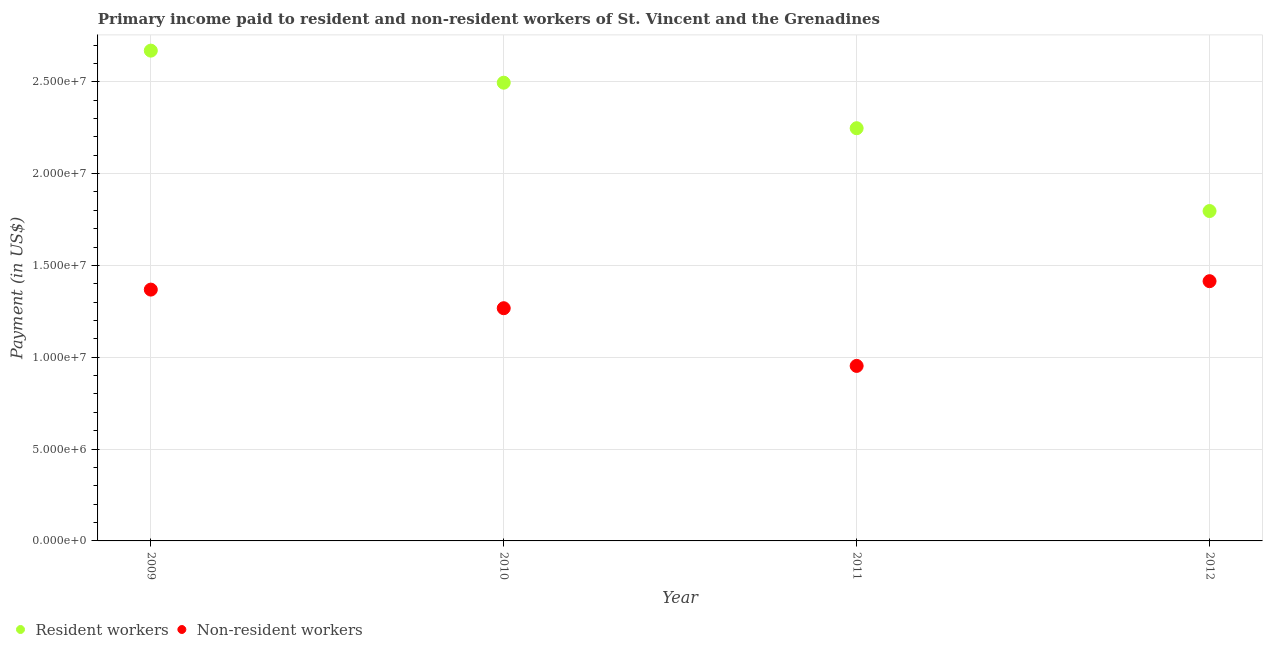How many different coloured dotlines are there?
Offer a terse response. 2. Is the number of dotlines equal to the number of legend labels?
Your answer should be very brief. Yes. What is the payment made to non-resident workers in 2010?
Your response must be concise. 1.27e+07. Across all years, what is the maximum payment made to non-resident workers?
Keep it short and to the point. 1.41e+07. Across all years, what is the minimum payment made to resident workers?
Your answer should be very brief. 1.80e+07. In which year was the payment made to non-resident workers maximum?
Offer a very short reply. 2012. In which year was the payment made to resident workers minimum?
Give a very brief answer. 2012. What is the total payment made to non-resident workers in the graph?
Make the answer very short. 5.00e+07. What is the difference between the payment made to non-resident workers in 2010 and that in 2011?
Your answer should be very brief. 3.14e+06. What is the difference between the payment made to non-resident workers in 2011 and the payment made to resident workers in 2009?
Your response must be concise. -1.72e+07. What is the average payment made to resident workers per year?
Offer a very short reply. 2.30e+07. In the year 2010, what is the difference between the payment made to non-resident workers and payment made to resident workers?
Give a very brief answer. -1.23e+07. What is the ratio of the payment made to resident workers in 2011 to that in 2012?
Ensure brevity in your answer.  1.25. Is the payment made to resident workers in 2010 less than that in 2011?
Ensure brevity in your answer.  No. What is the difference between the highest and the second highest payment made to non-resident workers?
Give a very brief answer. 4.58e+05. What is the difference between the highest and the lowest payment made to resident workers?
Provide a short and direct response. 8.73e+06. Is the sum of the payment made to non-resident workers in 2010 and 2011 greater than the maximum payment made to resident workers across all years?
Offer a terse response. No. Does the payment made to non-resident workers monotonically increase over the years?
Keep it short and to the point. No. Is the payment made to resident workers strictly greater than the payment made to non-resident workers over the years?
Keep it short and to the point. Yes. Is the payment made to resident workers strictly less than the payment made to non-resident workers over the years?
Give a very brief answer. No. How many years are there in the graph?
Provide a succinct answer. 4. Does the graph contain any zero values?
Ensure brevity in your answer.  No. Does the graph contain grids?
Give a very brief answer. Yes. Where does the legend appear in the graph?
Provide a succinct answer. Bottom left. What is the title of the graph?
Your answer should be compact. Primary income paid to resident and non-resident workers of St. Vincent and the Grenadines. What is the label or title of the Y-axis?
Keep it short and to the point. Payment (in US$). What is the Payment (in US$) of Resident workers in 2009?
Make the answer very short. 2.67e+07. What is the Payment (in US$) of Non-resident workers in 2009?
Make the answer very short. 1.37e+07. What is the Payment (in US$) of Resident workers in 2010?
Make the answer very short. 2.49e+07. What is the Payment (in US$) in Non-resident workers in 2010?
Provide a succinct answer. 1.27e+07. What is the Payment (in US$) of Resident workers in 2011?
Provide a succinct answer. 2.25e+07. What is the Payment (in US$) of Non-resident workers in 2011?
Your response must be concise. 9.53e+06. What is the Payment (in US$) of Resident workers in 2012?
Your answer should be compact. 1.80e+07. What is the Payment (in US$) in Non-resident workers in 2012?
Make the answer very short. 1.41e+07. Across all years, what is the maximum Payment (in US$) of Resident workers?
Provide a succinct answer. 2.67e+07. Across all years, what is the maximum Payment (in US$) in Non-resident workers?
Your answer should be very brief. 1.41e+07. Across all years, what is the minimum Payment (in US$) in Resident workers?
Provide a succinct answer. 1.80e+07. Across all years, what is the minimum Payment (in US$) in Non-resident workers?
Keep it short and to the point. 9.53e+06. What is the total Payment (in US$) in Resident workers in the graph?
Give a very brief answer. 9.21e+07. What is the total Payment (in US$) in Non-resident workers in the graph?
Provide a succinct answer. 5.00e+07. What is the difference between the Payment (in US$) in Resident workers in 2009 and that in 2010?
Keep it short and to the point. 1.75e+06. What is the difference between the Payment (in US$) in Non-resident workers in 2009 and that in 2010?
Ensure brevity in your answer.  1.01e+06. What is the difference between the Payment (in US$) in Resident workers in 2009 and that in 2011?
Make the answer very short. 4.22e+06. What is the difference between the Payment (in US$) in Non-resident workers in 2009 and that in 2011?
Ensure brevity in your answer.  4.16e+06. What is the difference between the Payment (in US$) of Resident workers in 2009 and that in 2012?
Provide a short and direct response. 8.73e+06. What is the difference between the Payment (in US$) of Non-resident workers in 2009 and that in 2012?
Your response must be concise. -4.58e+05. What is the difference between the Payment (in US$) of Resident workers in 2010 and that in 2011?
Your answer should be compact. 2.48e+06. What is the difference between the Payment (in US$) in Non-resident workers in 2010 and that in 2011?
Make the answer very short. 3.14e+06. What is the difference between the Payment (in US$) in Resident workers in 2010 and that in 2012?
Ensure brevity in your answer.  6.99e+06. What is the difference between the Payment (in US$) of Non-resident workers in 2010 and that in 2012?
Give a very brief answer. -1.47e+06. What is the difference between the Payment (in US$) of Resident workers in 2011 and that in 2012?
Your response must be concise. 4.51e+06. What is the difference between the Payment (in US$) of Non-resident workers in 2011 and that in 2012?
Your response must be concise. -4.61e+06. What is the difference between the Payment (in US$) of Resident workers in 2009 and the Payment (in US$) of Non-resident workers in 2010?
Your response must be concise. 1.40e+07. What is the difference between the Payment (in US$) in Resident workers in 2009 and the Payment (in US$) in Non-resident workers in 2011?
Ensure brevity in your answer.  1.72e+07. What is the difference between the Payment (in US$) of Resident workers in 2009 and the Payment (in US$) of Non-resident workers in 2012?
Your response must be concise. 1.26e+07. What is the difference between the Payment (in US$) of Resident workers in 2010 and the Payment (in US$) of Non-resident workers in 2011?
Your answer should be very brief. 1.54e+07. What is the difference between the Payment (in US$) of Resident workers in 2010 and the Payment (in US$) of Non-resident workers in 2012?
Ensure brevity in your answer.  1.08e+07. What is the difference between the Payment (in US$) in Resident workers in 2011 and the Payment (in US$) in Non-resident workers in 2012?
Provide a short and direct response. 8.33e+06. What is the average Payment (in US$) in Resident workers per year?
Provide a succinct answer. 2.30e+07. What is the average Payment (in US$) of Non-resident workers per year?
Offer a very short reply. 1.25e+07. In the year 2009, what is the difference between the Payment (in US$) in Resident workers and Payment (in US$) in Non-resident workers?
Offer a terse response. 1.30e+07. In the year 2010, what is the difference between the Payment (in US$) of Resident workers and Payment (in US$) of Non-resident workers?
Offer a very short reply. 1.23e+07. In the year 2011, what is the difference between the Payment (in US$) in Resident workers and Payment (in US$) in Non-resident workers?
Make the answer very short. 1.29e+07. In the year 2012, what is the difference between the Payment (in US$) of Resident workers and Payment (in US$) of Non-resident workers?
Provide a succinct answer. 3.82e+06. What is the ratio of the Payment (in US$) in Resident workers in 2009 to that in 2010?
Provide a short and direct response. 1.07. What is the ratio of the Payment (in US$) in Non-resident workers in 2009 to that in 2010?
Your answer should be very brief. 1.08. What is the ratio of the Payment (in US$) in Resident workers in 2009 to that in 2011?
Offer a very short reply. 1.19. What is the ratio of the Payment (in US$) of Non-resident workers in 2009 to that in 2011?
Make the answer very short. 1.44. What is the ratio of the Payment (in US$) in Resident workers in 2009 to that in 2012?
Offer a very short reply. 1.49. What is the ratio of the Payment (in US$) of Non-resident workers in 2009 to that in 2012?
Provide a succinct answer. 0.97. What is the ratio of the Payment (in US$) of Resident workers in 2010 to that in 2011?
Give a very brief answer. 1.11. What is the ratio of the Payment (in US$) in Non-resident workers in 2010 to that in 2011?
Provide a succinct answer. 1.33. What is the ratio of the Payment (in US$) in Resident workers in 2010 to that in 2012?
Your answer should be compact. 1.39. What is the ratio of the Payment (in US$) in Non-resident workers in 2010 to that in 2012?
Provide a short and direct response. 0.9. What is the ratio of the Payment (in US$) of Resident workers in 2011 to that in 2012?
Offer a terse response. 1.25. What is the ratio of the Payment (in US$) in Non-resident workers in 2011 to that in 2012?
Ensure brevity in your answer.  0.67. What is the difference between the highest and the second highest Payment (in US$) of Resident workers?
Provide a succinct answer. 1.75e+06. What is the difference between the highest and the second highest Payment (in US$) of Non-resident workers?
Your response must be concise. 4.58e+05. What is the difference between the highest and the lowest Payment (in US$) in Resident workers?
Your answer should be very brief. 8.73e+06. What is the difference between the highest and the lowest Payment (in US$) in Non-resident workers?
Offer a very short reply. 4.61e+06. 